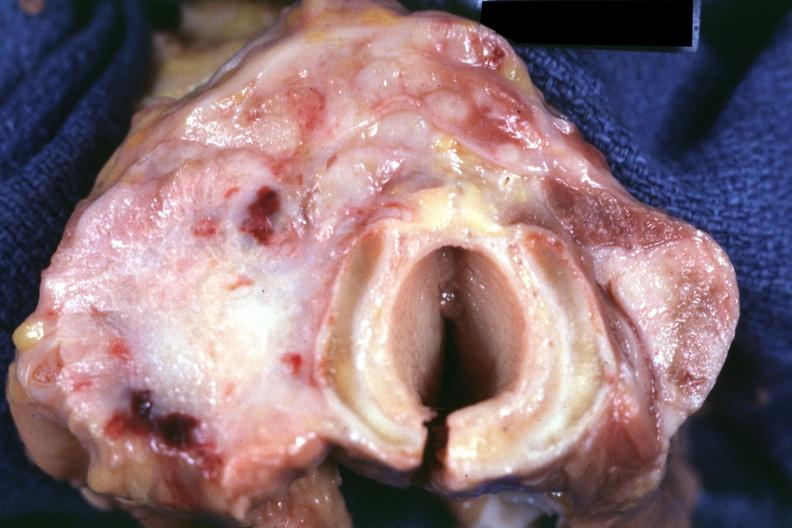what said to be undifferentiated carcinoma had metastases to lungs, pleura, liver and regional nodes 70yof also had colon carcinoma?
Answer the question using a single word or phrase. Fibrotic lesion 